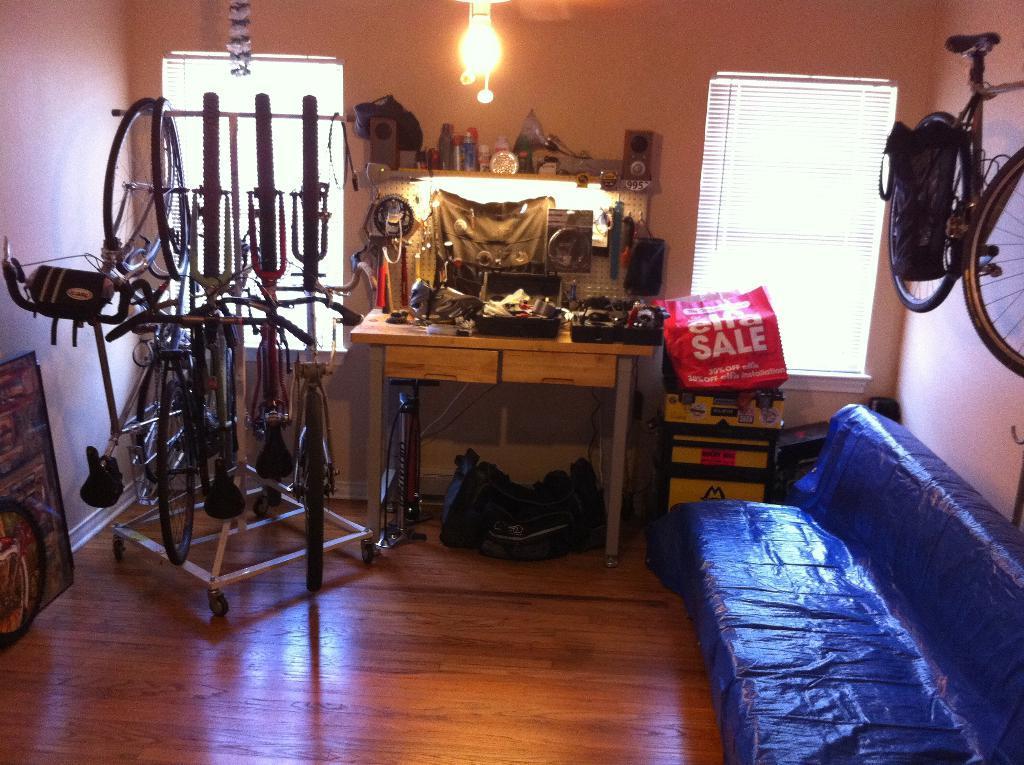Could you give a brief overview of what you see in this image? In this image there is a couch truncated towards the bottom of the image, there is a table, there are objects on the table, there are objects on the floor, there are objects truncated towards the left of the image, there is a wooden floor truncated towards the bottom of the image, there are windows, there is a wall truncated towards the top of the image, there is a bicycle truncated towards the right of the image, there is a wall truncated towards the right of the image, there is a light truncated towards the top of the image, there is an object truncated towards the top of the image, there is a wall truncated towards the left of the image. 